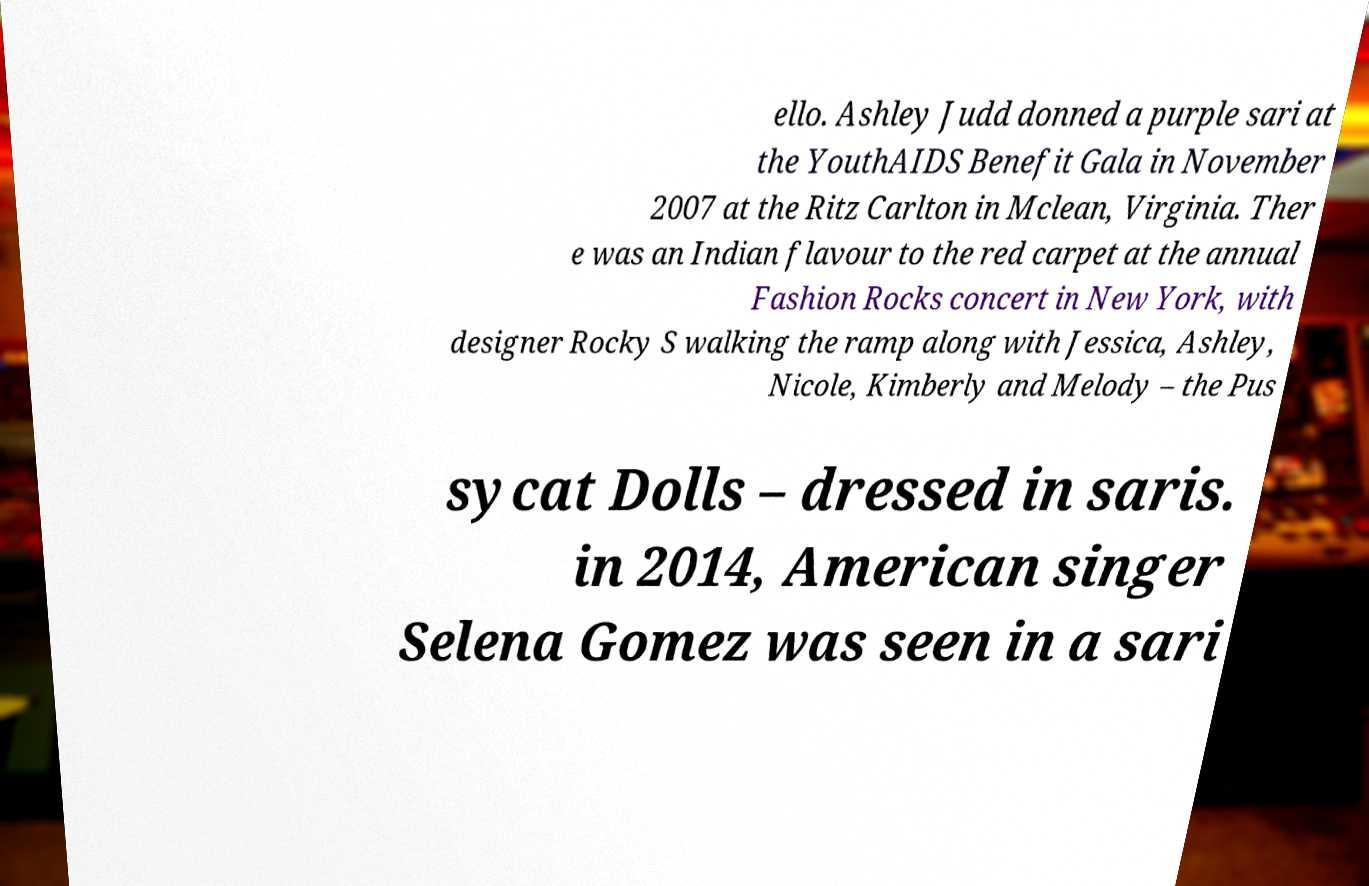Could you extract and type out the text from this image? ello. Ashley Judd donned a purple sari at the YouthAIDS Benefit Gala in November 2007 at the Ritz Carlton in Mclean, Virginia. Ther e was an Indian flavour to the red carpet at the annual Fashion Rocks concert in New York, with designer Rocky S walking the ramp along with Jessica, Ashley, Nicole, Kimberly and Melody – the Pus sycat Dolls – dressed in saris. in 2014, American singer Selena Gomez was seen in a sari 